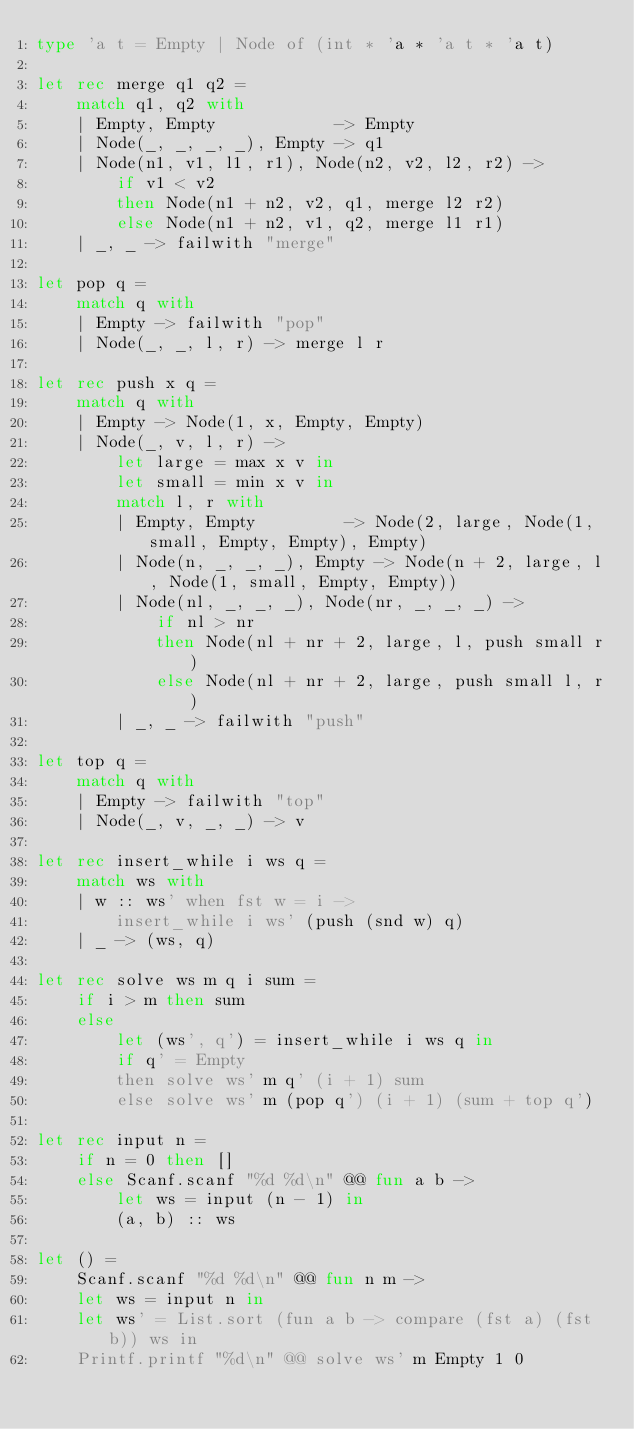Convert code to text. <code><loc_0><loc_0><loc_500><loc_500><_OCaml_>type 'a t = Empty | Node of (int * 'a * 'a t * 'a t)

let rec merge q1 q2 =
    match q1, q2 with
    | Empty, Empty            -> Empty
    | Node(_, _, _, _), Empty -> q1
    | Node(n1, v1, l1, r1), Node(n2, v2, l2, r2) ->
        if v1 < v2
        then Node(n1 + n2, v2, q1, merge l2 r2)
        else Node(n1 + n2, v1, q2, merge l1 r1)
    | _, _ -> failwith "merge"

let pop q =
    match q with
    | Empty -> failwith "pop"
    | Node(_, _, l, r) -> merge l r

let rec push x q =
    match q with
    | Empty -> Node(1, x, Empty, Empty)
    | Node(_, v, l, r) ->
        let large = max x v in
        let small = min x v in
        match l, r with
        | Empty, Empty         -> Node(2, large, Node(1, small, Empty, Empty), Empty)
        | Node(n, _, _, _), Empty -> Node(n + 2, large, l, Node(1, small, Empty, Empty))
        | Node(nl, _, _, _), Node(nr, _, _, _) ->
            if nl > nr
            then Node(nl + nr + 2, large, l, push small r)
            else Node(nl + nr + 2, large, push small l, r)
        | _, _ -> failwith "push"

let top q =
    match q with
    | Empty -> failwith "top"
    | Node(_, v, _, _) -> v

let rec insert_while i ws q =
    match ws with
    | w :: ws' when fst w = i ->
        insert_while i ws' (push (snd w) q)
    | _ -> (ws, q)

let rec solve ws m q i sum =
    if i > m then sum
    else
        let (ws', q') = insert_while i ws q in
        if q' = Empty
        then solve ws' m q' (i + 1) sum
        else solve ws' m (pop q') (i + 1) (sum + top q')

let rec input n =
    if n = 0 then []
    else Scanf.scanf "%d %d\n" @@ fun a b ->
        let ws = input (n - 1) in
        (a, b) :: ws

let () =
    Scanf.scanf "%d %d\n" @@ fun n m ->
    let ws = input n in
    let ws' = List.sort (fun a b -> compare (fst a) (fst b)) ws in
    Printf.printf "%d\n" @@ solve ws' m Empty 1 0
</code> 